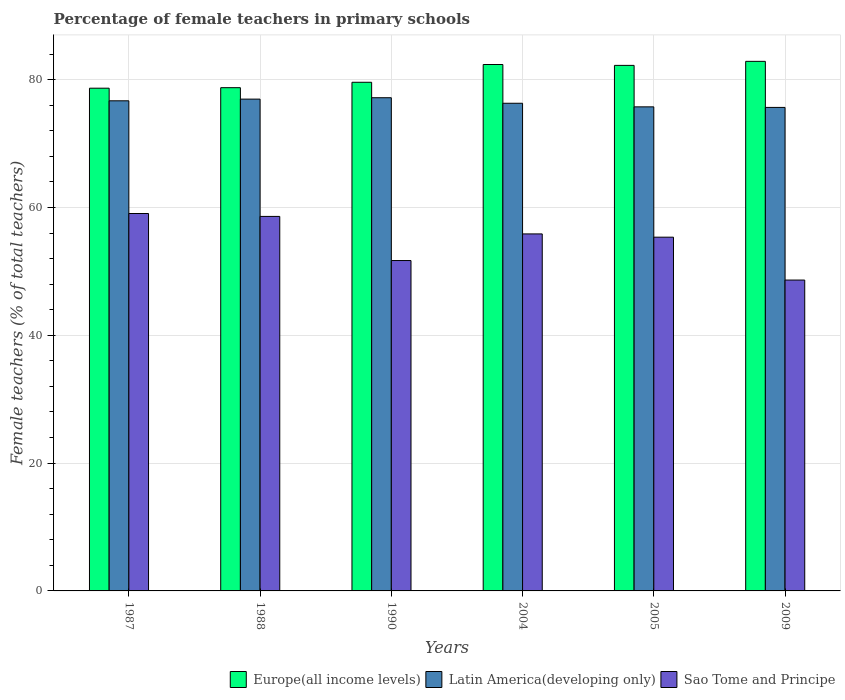How many different coloured bars are there?
Your response must be concise. 3. How many groups of bars are there?
Provide a succinct answer. 6. Are the number of bars per tick equal to the number of legend labels?
Your answer should be compact. Yes. Are the number of bars on each tick of the X-axis equal?
Ensure brevity in your answer.  Yes. How many bars are there on the 5th tick from the left?
Your response must be concise. 3. How many bars are there on the 1st tick from the right?
Offer a very short reply. 3. What is the percentage of female teachers in Sao Tome and Principe in 2005?
Offer a very short reply. 55.35. Across all years, what is the maximum percentage of female teachers in Sao Tome and Principe?
Provide a succinct answer. 59.06. Across all years, what is the minimum percentage of female teachers in Europe(all income levels)?
Make the answer very short. 78.67. In which year was the percentage of female teachers in Europe(all income levels) maximum?
Ensure brevity in your answer.  2009. In which year was the percentage of female teachers in Latin America(developing only) minimum?
Make the answer very short. 2009. What is the total percentage of female teachers in Sao Tome and Principe in the graph?
Offer a very short reply. 329.23. What is the difference between the percentage of female teachers in Sao Tome and Principe in 1987 and that in 2009?
Your answer should be compact. 10.41. What is the difference between the percentage of female teachers in Sao Tome and Principe in 2005 and the percentage of female teachers in Europe(all income levels) in 1990?
Your answer should be compact. -24.24. What is the average percentage of female teachers in Latin America(developing only) per year?
Ensure brevity in your answer.  76.42. In the year 1987, what is the difference between the percentage of female teachers in Sao Tome and Principe and percentage of female teachers in Latin America(developing only)?
Offer a very short reply. -17.64. What is the ratio of the percentage of female teachers in Europe(all income levels) in 1990 to that in 2009?
Make the answer very short. 0.96. Is the percentage of female teachers in Sao Tome and Principe in 2004 less than that in 2005?
Your response must be concise. No. What is the difference between the highest and the second highest percentage of female teachers in Sao Tome and Principe?
Your answer should be compact. 0.46. What is the difference between the highest and the lowest percentage of female teachers in Latin America(developing only)?
Keep it short and to the point. 1.52. In how many years, is the percentage of female teachers in Latin America(developing only) greater than the average percentage of female teachers in Latin America(developing only) taken over all years?
Make the answer very short. 3. Is the sum of the percentage of female teachers in Latin America(developing only) in 2005 and 2009 greater than the maximum percentage of female teachers in Sao Tome and Principe across all years?
Keep it short and to the point. Yes. What does the 3rd bar from the left in 1988 represents?
Provide a short and direct response. Sao Tome and Principe. What does the 1st bar from the right in 2005 represents?
Offer a very short reply. Sao Tome and Principe. Is it the case that in every year, the sum of the percentage of female teachers in Sao Tome and Principe and percentage of female teachers in Latin America(developing only) is greater than the percentage of female teachers in Europe(all income levels)?
Keep it short and to the point. Yes. How many bars are there?
Provide a short and direct response. 18. Are all the bars in the graph horizontal?
Provide a short and direct response. No. How many years are there in the graph?
Provide a short and direct response. 6. Are the values on the major ticks of Y-axis written in scientific E-notation?
Keep it short and to the point. No. Where does the legend appear in the graph?
Provide a succinct answer. Bottom right. What is the title of the graph?
Keep it short and to the point. Percentage of female teachers in primary schools. What is the label or title of the X-axis?
Keep it short and to the point. Years. What is the label or title of the Y-axis?
Offer a very short reply. Female teachers (% of total teachers). What is the Female teachers (% of total teachers) in Europe(all income levels) in 1987?
Keep it short and to the point. 78.67. What is the Female teachers (% of total teachers) in Latin America(developing only) in 1987?
Provide a short and direct response. 76.7. What is the Female teachers (% of total teachers) in Sao Tome and Principe in 1987?
Your response must be concise. 59.06. What is the Female teachers (% of total teachers) of Europe(all income levels) in 1988?
Your response must be concise. 78.75. What is the Female teachers (% of total teachers) in Latin America(developing only) in 1988?
Provide a succinct answer. 76.96. What is the Female teachers (% of total teachers) in Sao Tome and Principe in 1988?
Make the answer very short. 58.6. What is the Female teachers (% of total teachers) of Europe(all income levels) in 1990?
Ensure brevity in your answer.  79.6. What is the Female teachers (% of total teachers) of Latin America(developing only) in 1990?
Give a very brief answer. 77.18. What is the Female teachers (% of total teachers) in Sao Tome and Principe in 1990?
Ensure brevity in your answer.  51.7. What is the Female teachers (% of total teachers) in Europe(all income levels) in 2004?
Give a very brief answer. 82.37. What is the Female teachers (% of total teachers) in Latin America(developing only) in 2004?
Ensure brevity in your answer.  76.31. What is the Female teachers (% of total teachers) in Sao Tome and Principe in 2004?
Give a very brief answer. 55.87. What is the Female teachers (% of total teachers) in Europe(all income levels) in 2005?
Keep it short and to the point. 82.24. What is the Female teachers (% of total teachers) of Latin America(developing only) in 2005?
Your response must be concise. 75.75. What is the Female teachers (% of total teachers) in Sao Tome and Principe in 2005?
Provide a short and direct response. 55.35. What is the Female teachers (% of total teachers) in Europe(all income levels) in 2009?
Offer a terse response. 82.87. What is the Female teachers (% of total teachers) in Latin America(developing only) in 2009?
Offer a very short reply. 75.66. What is the Female teachers (% of total teachers) of Sao Tome and Principe in 2009?
Offer a terse response. 48.64. Across all years, what is the maximum Female teachers (% of total teachers) in Europe(all income levels)?
Offer a terse response. 82.87. Across all years, what is the maximum Female teachers (% of total teachers) of Latin America(developing only)?
Your answer should be compact. 77.18. Across all years, what is the maximum Female teachers (% of total teachers) of Sao Tome and Principe?
Provide a short and direct response. 59.06. Across all years, what is the minimum Female teachers (% of total teachers) of Europe(all income levels)?
Ensure brevity in your answer.  78.67. Across all years, what is the minimum Female teachers (% of total teachers) in Latin America(developing only)?
Make the answer very short. 75.66. Across all years, what is the minimum Female teachers (% of total teachers) of Sao Tome and Principe?
Give a very brief answer. 48.64. What is the total Female teachers (% of total teachers) in Europe(all income levels) in the graph?
Your answer should be compact. 484.49. What is the total Female teachers (% of total teachers) of Latin America(developing only) in the graph?
Make the answer very short. 458.55. What is the total Female teachers (% of total teachers) of Sao Tome and Principe in the graph?
Keep it short and to the point. 329.23. What is the difference between the Female teachers (% of total teachers) in Europe(all income levels) in 1987 and that in 1988?
Offer a very short reply. -0.08. What is the difference between the Female teachers (% of total teachers) in Latin America(developing only) in 1987 and that in 1988?
Provide a succinct answer. -0.26. What is the difference between the Female teachers (% of total teachers) in Sao Tome and Principe in 1987 and that in 1988?
Your answer should be very brief. 0.46. What is the difference between the Female teachers (% of total teachers) of Europe(all income levels) in 1987 and that in 1990?
Provide a succinct answer. -0.93. What is the difference between the Female teachers (% of total teachers) in Latin America(developing only) in 1987 and that in 1990?
Offer a terse response. -0.48. What is the difference between the Female teachers (% of total teachers) of Sao Tome and Principe in 1987 and that in 1990?
Provide a short and direct response. 7.36. What is the difference between the Female teachers (% of total teachers) of Europe(all income levels) in 1987 and that in 2004?
Your response must be concise. -3.71. What is the difference between the Female teachers (% of total teachers) of Latin America(developing only) in 1987 and that in 2004?
Give a very brief answer. 0.39. What is the difference between the Female teachers (% of total teachers) of Sao Tome and Principe in 1987 and that in 2004?
Your answer should be very brief. 3.19. What is the difference between the Female teachers (% of total teachers) of Europe(all income levels) in 1987 and that in 2005?
Your response must be concise. -3.57. What is the difference between the Female teachers (% of total teachers) of Latin America(developing only) in 1987 and that in 2005?
Make the answer very short. 0.95. What is the difference between the Female teachers (% of total teachers) in Sao Tome and Principe in 1987 and that in 2005?
Provide a succinct answer. 3.71. What is the difference between the Female teachers (% of total teachers) of Europe(all income levels) in 1987 and that in 2009?
Ensure brevity in your answer.  -4.2. What is the difference between the Female teachers (% of total teachers) in Latin America(developing only) in 1987 and that in 2009?
Your answer should be compact. 1.04. What is the difference between the Female teachers (% of total teachers) in Sao Tome and Principe in 1987 and that in 2009?
Your answer should be compact. 10.41. What is the difference between the Female teachers (% of total teachers) of Europe(all income levels) in 1988 and that in 1990?
Your answer should be compact. -0.85. What is the difference between the Female teachers (% of total teachers) in Latin America(developing only) in 1988 and that in 1990?
Ensure brevity in your answer.  -0.22. What is the difference between the Female teachers (% of total teachers) of Sao Tome and Principe in 1988 and that in 1990?
Offer a very short reply. 6.9. What is the difference between the Female teachers (% of total teachers) of Europe(all income levels) in 1988 and that in 2004?
Offer a very short reply. -3.62. What is the difference between the Female teachers (% of total teachers) in Latin America(developing only) in 1988 and that in 2004?
Ensure brevity in your answer.  0.65. What is the difference between the Female teachers (% of total teachers) in Sao Tome and Principe in 1988 and that in 2004?
Ensure brevity in your answer.  2.74. What is the difference between the Female teachers (% of total teachers) in Europe(all income levels) in 1988 and that in 2005?
Offer a very short reply. -3.49. What is the difference between the Female teachers (% of total teachers) of Latin America(developing only) in 1988 and that in 2005?
Ensure brevity in your answer.  1.21. What is the difference between the Female teachers (% of total teachers) in Sao Tome and Principe in 1988 and that in 2005?
Make the answer very short. 3.25. What is the difference between the Female teachers (% of total teachers) in Europe(all income levels) in 1988 and that in 2009?
Make the answer very short. -4.12. What is the difference between the Female teachers (% of total teachers) in Latin America(developing only) in 1988 and that in 2009?
Ensure brevity in your answer.  1.3. What is the difference between the Female teachers (% of total teachers) in Sao Tome and Principe in 1988 and that in 2009?
Make the answer very short. 9.96. What is the difference between the Female teachers (% of total teachers) of Europe(all income levels) in 1990 and that in 2004?
Offer a terse response. -2.78. What is the difference between the Female teachers (% of total teachers) in Latin America(developing only) in 1990 and that in 2004?
Provide a short and direct response. 0.86. What is the difference between the Female teachers (% of total teachers) of Sao Tome and Principe in 1990 and that in 2004?
Provide a succinct answer. -4.17. What is the difference between the Female teachers (% of total teachers) in Europe(all income levels) in 1990 and that in 2005?
Give a very brief answer. -2.64. What is the difference between the Female teachers (% of total teachers) in Latin America(developing only) in 1990 and that in 2005?
Provide a succinct answer. 1.43. What is the difference between the Female teachers (% of total teachers) of Sao Tome and Principe in 1990 and that in 2005?
Offer a terse response. -3.65. What is the difference between the Female teachers (% of total teachers) in Europe(all income levels) in 1990 and that in 2009?
Provide a short and direct response. -3.27. What is the difference between the Female teachers (% of total teachers) of Latin America(developing only) in 1990 and that in 2009?
Give a very brief answer. 1.52. What is the difference between the Female teachers (% of total teachers) of Sao Tome and Principe in 1990 and that in 2009?
Provide a short and direct response. 3.06. What is the difference between the Female teachers (% of total teachers) in Europe(all income levels) in 2004 and that in 2005?
Your answer should be compact. 0.14. What is the difference between the Female teachers (% of total teachers) in Latin America(developing only) in 2004 and that in 2005?
Provide a short and direct response. 0.56. What is the difference between the Female teachers (% of total teachers) of Sao Tome and Principe in 2004 and that in 2005?
Offer a very short reply. 0.51. What is the difference between the Female teachers (% of total teachers) in Europe(all income levels) in 2004 and that in 2009?
Provide a succinct answer. -0.49. What is the difference between the Female teachers (% of total teachers) of Latin America(developing only) in 2004 and that in 2009?
Your response must be concise. 0.65. What is the difference between the Female teachers (% of total teachers) of Sao Tome and Principe in 2004 and that in 2009?
Make the answer very short. 7.22. What is the difference between the Female teachers (% of total teachers) of Europe(all income levels) in 2005 and that in 2009?
Make the answer very short. -0.63. What is the difference between the Female teachers (% of total teachers) of Latin America(developing only) in 2005 and that in 2009?
Your response must be concise. 0.09. What is the difference between the Female teachers (% of total teachers) of Sao Tome and Principe in 2005 and that in 2009?
Keep it short and to the point. 6.71. What is the difference between the Female teachers (% of total teachers) of Europe(all income levels) in 1987 and the Female teachers (% of total teachers) of Latin America(developing only) in 1988?
Your response must be concise. 1.71. What is the difference between the Female teachers (% of total teachers) in Europe(all income levels) in 1987 and the Female teachers (% of total teachers) in Sao Tome and Principe in 1988?
Your answer should be compact. 20.06. What is the difference between the Female teachers (% of total teachers) of Latin America(developing only) in 1987 and the Female teachers (% of total teachers) of Sao Tome and Principe in 1988?
Your answer should be very brief. 18.09. What is the difference between the Female teachers (% of total teachers) of Europe(all income levels) in 1987 and the Female teachers (% of total teachers) of Latin America(developing only) in 1990?
Offer a terse response. 1.49. What is the difference between the Female teachers (% of total teachers) in Europe(all income levels) in 1987 and the Female teachers (% of total teachers) in Sao Tome and Principe in 1990?
Make the answer very short. 26.97. What is the difference between the Female teachers (% of total teachers) of Latin America(developing only) in 1987 and the Female teachers (% of total teachers) of Sao Tome and Principe in 1990?
Keep it short and to the point. 25. What is the difference between the Female teachers (% of total teachers) in Europe(all income levels) in 1987 and the Female teachers (% of total teachers) in Latin America(developing only) in 2004?
Provide a short and direct response. 2.36. What is the difference between the Female teachers (% of total teachers) of Europe(all income levels) in 1987 and the Female teachers (% of total teachers) of Sao Tome and Principe in 2004?
Offer a very short reply. 22.8. What is the difference between the Female teachers (% of total teachers) in Latin America(developing only) in 1987 and the Female teachers (% of total teachers) in Sao Tome and Principe in 2004?
Offer a very short reply. 20.83. What is the difference between the Female teachers (% of total teachers) in Europe(all income levels) in 1987 and the Female teachers (% of total teachers) in Latin America(developing only) in 2005?
Offer a very short reply. 2.92. What is the difference between the Female teachers (% of total teachers) in Europe(all income levels) in 1987 and the Female teachers (% of total teachers) in Sao Tome and Principe in 2005?
Offer a very short reply. 23.31. What is the difference between the Female teachers (% of total teachers) of Latin America(developing only) in 1987 and the Female teachers (% of total teachers) of Sao Tome and Principe in 2005?
Offer a very short reply. 21.34. What is the difference between the Female teachers (% of total teachers) in Europe(all income levels) in 1987 and the Female teachers (% of total teachers) in Latin America(developing only) in 2009?
Ensure brevity in your answer.  3.01. What is the difference between the Female teachers (% of total teachers) in Europe(all income levels) in 1987 and the Female teachers (% of total teachers) in Sao Tome and Principe in 2009?
Keep it short and to the point. 30.02. What is the difference between the Female teachers (% of total teachers) of Latin America(developing only) in 1987 and the Female teachers (% of total teachers) of Sao Tome and Principe in 2009?
Keep it short and to the point. 28.05. What is the difference between the Female teachers (% of total teachers) of Europe(all income levels) in 1988 and the Female teachers (% of total teachers) of Latin America(developing only) in 1990?
Keep it short and to the point. 1.57. What is the difference between the Female teachers (% of total teachers) of Europe(all income levels) in 1988 and the Female teachers (% of total teachers) of Sao Tome and Principe in 1990?
Your answer should be compact. 27.05. What is the difference between the Female teachers (% of total teachers) of Latin America(developing only) in 1988 and the Female teachers (% of total teachers) of Sao Tome and Principe in 1990?
Make the answer very short. 25.26. What is the difference between the Female teachers (% of total teachers) in Europe(all income levels) in 1988 and the Female teachers (% of total teachers) in Latin America(developing only) in 2004?
Your answer should be compact. 2.44. What is the difference between the Female teachers (% of total teachers) of Europe(all income levels) in 1988 and the Female teachers (% of total teachers) of Sao Tome and Principe in 2004?
Make the answer very short. 22.88. What is the difference between the Female teachers (% of total teachers) in Latin America(developing only) in 1988 and the Female teachers (% of total teachers) in Sao Tome and Principe in 2004?
Provide a short and direct response. 21.09. What is the difference between the Female teachers (% of total teachers) in Europe(all income levels) in 1988 and the Female teachers (% of total teachers) in Latin America(developing only) in 2005?
Keep it short and to the point. 3. What is the difference between the Female teachers (% of total teachers) in Europe(all income levels) in 1988 and the Female teachers (% of total teachers) in Sao Tome and Principe in 2005?
Your answer should be compact. 23.4. What is the difference between the Female teachers (% of total teachers) in Latin America(developing only) in 1988 and the Female teachers (% of total teachers) in Sao Tome and Principe in 2005?
Provide a succinct answer. 21.6. What is the difference between the Female teachers (% of total teachers) in Europe(all income levels) in 1988 and the Female teachers (% of total teachers) in Latin America(developing only) in 2009?
Ensure brevity in your answer.  3.09. What is the difference between the Female teachers (% of total teachers) of Europe(all income levels) in 1988 and the Female teachers (% of total teachers) of Sao Tome and Principe in 2009?
Provide a short and direct response. 30.1. What is the difference between the Female teachers (% of total teachers) of Latin America(developing only) in 1988 and the Female teachers (% of total teachers) of Sao Tome and Principe in 2009?
Offer a terse response. 28.31. What is the difference between the Female teachers (% of total teachers) of Europe(all income levels) in 1990 and the Female teachers (% of total teachers) of Latin America(developing only) in 2004?
Your answer should be compact. 3.29. What is the difference between the Female teachers (% of total teachers) in Europe(all income levels) in 1990 and the Female teachers (% of total teachers) in Sao Tome and Principe in 2004?
Your response must be concise. 23.73. What is the difference between the Female teachers (% of total teachers) in Latin America(developing only) in 1990 and the Female teachers (% of total teachers) in Sao Tome and Principe in 2004?
Make the answer very short. 21.31. What is the difference between the Female teachers (% of total teachers) of Europe(all income levels) in 1990 and the Female teachers (% of total teachers) of Latin America(developing only) in 2005?
Ensure brevity in your answer.  3.85. What is the difference between the Female teachers (% of total teachers) in Europe(all income levels) in 1990 and the Female teachers (% of total teachers) in Sao Tome and Principe in 2005?
Keep it short and to the point. 24.24. What is the difference between the Female teachers (% of total teachers) in Latin America(developing only) in 1990 and the Female teachers (% of total teachers) in Sao Tome and Principe in 2005?
Give a very brief answer. 21.82. What is the difference between the Female teachers (% of total teachers) of Europe(all income levels) in 1990 and the Female teachers (% of total teachers) of Latin America(developing only) in 2009?
Keep it short and to the point. 3.94. What is the difference between the Female teachers (% of total teachers) in Europe(all income levels) in 1990 and the Female teachers (% of total teachers) in Sao Tome and Principe in 2009?
Ensure brevity in your answer.  30.95. What is the difference between the Female teachers (% of total teachers) of Latin America(developing only) in 1990 and the Female teachers (% of total teachers) of Sao Tome and Principe in 2009?
Keep it short and to the point. 28.53. What is the difference between the Female teachers (% of total teachers) in Europe(all income levels) in 2004 and the Female teachers (% of total teachers) in Latin America(developing only) in 2005?
Your answer should be very brief. 6.63. What is the difference between the Female teachers (% of total teachers) in Europe(all income levels) in 2004 and the Female teachers (% of total teachers) in Sao Tome and Principe in 2005?
Keep it short and to the point. 27.02. What is the difference between the Female teachers (% of total teachers) of Latin America(developing only) in 2004 and the Female teachers (% of total teachers) of Sao Tome and Principe in 2005?
Give a very brief answer. 20.96. What is the difference between the Female teachers (% of total teachers) in Europe(all income levels) in 2004 and the Female teachers (% of total teachers) in Latin America(developing only) in 2009?
Provide a succinct answer. 6.71. What is the difference between the Female teachers (% of total teachers) of Europe(all income levels) in 2004 and the Female teachers (% of total teachers) of Sao Tome and Principe in 2009?
Your response must be concise. 33.73. What is the difference between the Female teachers (% of total teachers) in Latin America(developing only) in 2004 and the Female teachers (% of total teachers) in Sao Tome and Principe in 2009?
Keep it short and to the point. 27.67. What is the difference between the Female teachers (% of total teachers) in Europe(all income levels) in 2005 and the Female teachers (% of total teachers) in Latin America(developing only) in 2009?
Keep it short and to the point. 6.58. What is the difference between the Female teachers (% of total teachers) of Europe(all income levels) in 2005 and the Female teachers (% of total teachers) of Sao Tome and Principe in 2009?
Give a very brief answer. 33.59. What is the difference between the Female teachers (% of total teachers) of Latin America(developing only) in 2005 and the Female teachers (% of total teachers) of Sao Tome and Principe in 2009?
Offer a very short reply. 27.1. What is the average Female teachers (% of total teachers) of Europe(all income levels) per year?
Offer a very short reply. 80.75. What is the average Female teachers (% of total teachers) in Latin America(developing only) per year?
Make the answer very short. 76.42. What is the average Female teachers (% of total teachers) of Sao Tome and Principe per year?
Keep it short and to the point. 54.87. In the year 1987, what is the difference between the Female teachers (% of total teachers) in Europe(all income levels) and Female teachers (% of total teachers) in Latin America(developing only)?
Your answer should be very brief. 1.97. In the year 1987, what is the difference between the Female teachers (% of total teachers) in Europe(all income levels) and Female teachers (% of total teachers) in Sao Tome and Principe?
Provide a succinct answer. 19.61. In the year 1987, what is the difference between the Female teachers (% of total teachers) in Latin America(developing only) and Female teachers (% of total teachers) in Sao Tome and Principe?
Give a very brief answer. 17.64. In the year 1988, what is the difference between the Female teachers (% of total teachers) of Europe(all income levels) and Female teachers (% of total teachers) of Latin America(developing only)?
Provide a short and direct response. 1.79. In the year 1988, what is the difference between the Female teachers (% of total teachers) in Europe(all income levels) and Female teachers (% of total teachers) in Sao Tome and Principe?
Offer a very short reply. 20.14. In the year 1988, what is the difference between the Female teachers (% of total teachers) of Latin America(developing only) and Female teachers (% of total teachers) of Sao Tome and Principe?
Offer a terse response. 18.35. In the year 1990, what is the difference between the Female teachers (% of total teachers) in Europe(all income levels) and Female teachers (% of total teachers) in Latin America(developing only)?
Make the answer very short. 2.42. In the year 1990, what is the difference between the Female teachers (% of total teachers) in Europe(all income levels) and Female teachers (% of total teachers) in Sao Tome and Principe?
Your answer should be very brief. 27.9. In the year 1990, what is the difference between the Female teachers (% of total teachers) in Latin America(developing only) and Female teachers (% of total teachers) in Sao Tome and Principe?
Ensure brevity in your answer.  25.48. In the year 2004, what is the difference between the Female teachers (% of total teachers) of Europe(all income levels) and Female teachers (% of total teachers) of Latin America(developing only)?
Offer a very short reply. 6.06. In the year 2004, what is the difference between the Female teachers (% of total teachers) of Europe(all income levels) and Female teachers (% of total teachers) of Sao Tome and Principe?
Your answer should be compact. 26.51. In the year 2004, what is the difference between the Female teachers (% of total teachers) in Latin America(developing only) and Female teachers (% of total teachers) in Sao Tome and Principe?
Give a very brief answer. 20.44. In the year 2005, what is the difference between the Female teachers (% of total teachers) in Europe(all income levels) and Female teachers (% of total teachers) in Latin America(developing only)?
Offer a terse response. 6.49. In the year 2005, what is the difference between the Female teachers (% of total teachers) of Europe(all income levels) and Female teachers (% of total teachers) of Sao Tome and Principe?
Ensure brevity in your answer.  26.89. In the year 2005, what is the difference between the Female teachers (% of total teachers) in Latin America(developing only) and Female teachers (% of total teachers) in Sao Tome and Principe?
Your answer should be compact. 20.39. In the year 2009, what is the difference between the Female teachers (% of total teachers) in Europe(all income levels) and Female teachers (% of total teachers) in Latin America(developing only)?
Your answer should be very brief. 7.21. In the year 2009, what is the difference between the Female teachers (% of total teachers) of Europe(all income levels) and Female teachers (% of total teachers) of Sao Tome and Principe?
Keep it short and to the point. 34.22. In the year 2009, what is the difference between the Female teachers (% of total teachers) in Latin America(developing only) and Female teachers (% of total teachers) in Sao Tome and Principe?
Make the answer very short. 27.02. What is the ratio of the Female teachers (% of total teachers) in Europe(all income levels) in 1987 to that in 1990?
Your answer should be compact. 0.99. What is the ratio of the Female teachers (% of total teachers) in Sao Tome and Principe in 1987 to that in 1990?
Your answer should be compact. 1.14. What is the ratio of the Female teachers (% of total teachers) of Europe(all income levels) in 1987 to that in 2004?
Make the answer very short. 0.95. What is the ratio of the Female teachers (% of total teachers) of Latin America(developing only) in 1987 to that in 2004?
Make the answer very short. 1. What is the ratio of the Female teachers (% of total teachers) of Sao Tome and Principe in 1987 to that in 2004?
Ensure brevity in your answer.  1.06. What is the ratio of the Female teachers (% of total teachers) in Europe(all income levels) in 1987 to that in 2005?
Make the answer very short. 0.96. What is the ratio of the Female teachers (% of total teachers) of Latin America(developing only) in 1987 to that in 2005?
Provide a succinct answer. 1.01. What is the ratio of the Female teachers (% of total teachers) of Sao Tome and Principe in 1987 to that in 2005?
Your response must be concise. 1.07. What is the ratio of the Female teachers (% of total teachers) of Europe(all income levels) in 1987 to that in 2009?
Your response must be concise. 0.95. What is the ratio of the Female teachers (% of total teachers) in Latin America(developing only) in 1987 to that in 2009?
Your answer should be very brief. 1.01. What is the ratio of the Female teachers (% of total teachers) in Sao Tome and Principe in 1987 to that in 2009?
Make the answer very short. 1.21. What is the ratio of the Female teachers (% of total teachers) in Europe(all income levels) in 1988 to that in 1990?
Keep it short and to the point. 0.99. What is the ratio of the Female teachers (% of total teachers) in Latin America(developing only) in 1988 to that in 1990?
Provide a short and direct response. 1. What is the ratio of the Female teachers (% of total teachers) in Sao Tome and Principe in 1988 to that in 1990?
Make the answer very short. 1.13. What is the ratio of the Female teachers (% of total teachers) in Europe(all income levels) in 1988 to that in 2004?
Give a very brief answer. 0.96. What is the ratio of the Female teachers (% of total teachers) of Latin America(developing only) in 1988 to that in 2004?
Your answer should be very brief. 1.01. What is the ratio of the Female teachers (% of total teachers) of Sao Tome and Principe in 1988 to that in 2004?
Your answer should be compact. 1.05. What is the ratio of the Female teachers (% of total teachers) of Europe(all income levels) in 1988 to that in 2005?
Your answer should be compact. 0.96. What is the ratio of the Female teachers (% of total teachers) in Latin America(developing only) in 1988 to that in 2005?
Your answer should be compact. 1.02. What is the ratio of the Female teachers (% of total teachers) in Sao Tome and Principe in 1988 to that in 2005?
Ensure brevity in your answer.  1.06. What is the ratio of the Female teachers (% of total teachers) of Europe(all income levels) in 1988 to that in 2009?
Offer a very short reply. 0.95. What is the ratio of the Female teachers (% of total teachers) of Latin America(developing only) in 1988 to that in 2009?
Your answer should be compact. 1.02. What is the ratio of the Female teachers (% of total teachers) of Sao Tome and Principe in 1988 to that in 2009?
Provide a succinct answer. 1.2. What is the ratio of the Female teachers (% of total teachers) of Europe(all income levels) in 1990 to that in 2004?
Provide a short and direct response. 0.97. What is the ratio of the Female teachers (% of total teachers) of Latin America(developing only) in 1990 to that in 2004?
Your answer should be very brief. 1.01. What is the ratio of the Female teachers (% of total teachers) in Sao Tome and Principe in 1990 to that in 2004?
Make the answer very short. 0.93. What is the ratio of the Female teachers (% of total teachers) of Europe(all income levels) in 1990 to that in 2005?
Ensure brevity in your answer.  0.97. What is the ratio of the Female teachers (% of total teachers) of Latin America(developing only) in 1990 to that in 2005?
Provide a succinct answer. 1.02. What is the ratio of the Female teachers (% of total teachers) in Sao Tome and Principe in 1990 to that in 2005?
Ensure brevity in your answer.  0.93. What is the ratio of the Female teachers (% of total teachers) in Europe(all income levels) in 1990 to that in 2009?
Provide a short and direct response. 0.96. What is the ratio of the Female teachers (% of total teachers) of Sao Tome and Principe in 1990 to that in 2009?
Ensure brevity in your answer.  1.06. What is the ratio of the Female teachers (% of total teachers) in Latin America(developing only) in 2004 to that in 2005?
Ensure brevity in your answer.  1.01. What is the ratio of the Female teachers (% of total teachers) of Sao Tome and Principe in 2004 to that in 2005?
Make the answer very short. 1.01. What is the ratio of the Female teachers (% of total teachers) of Latin America(developing only) in 2004 to that in 2009?
Offer a terse response. 1.01. What is the ratio of the Female teachers (% of total teachers) of Sao Tome and Principe in 2004 to that in 2009?
Your answer should be compact. 1.15. What is the ratio of the Female teachers (% of total teachers) of Europe(all income levels) in 2005 to that in 2009?
Offer a terse response. 0.99. What is the ratio of the Female teachers (% of total teachers) of Latin America(developing only) in 2005 to that in 2009?
Offer a terse response. 1. What is the ratio of the Female teachers (% of total teachers) in Sao Tome and Principe in 2005 to that in 2009?
Provide a short and direct response. 1.14. What is the difference between the highest and the second highest Female teachers (% of total teachers) in Europe(all income levels)?
Give a very brief answer. 0.49. What is the difference between the highest and the second highest Female teachers (% of total teachers) in Latin America(developing only)?
Your answer should be compact. 0.22. What is the difference between the highest and the second highest Female teachers (% of total teachers) of Sao Tome and Principe?
Provide a succinct answer. 0.46. What is the difference between the highest and the lowest Female teachers (% of total teachers) in Europe(all income levels)?
Provide a succinct answer. 4.2. What is the difference between the highest and the lowest Female teachers (% of total teachers) of Latin America(developing only)?
Your answer should be very brief. 1.52. What is the difference between the highest and the lowest Female teachers (% of total teachers) in Sao Tome and Principe?
Your response must be concise. 10.41. 